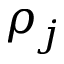Convert formula to latex. <formula><loc_0><loc_0><loc_500><loc_500>\rho _ { j }</formula> 